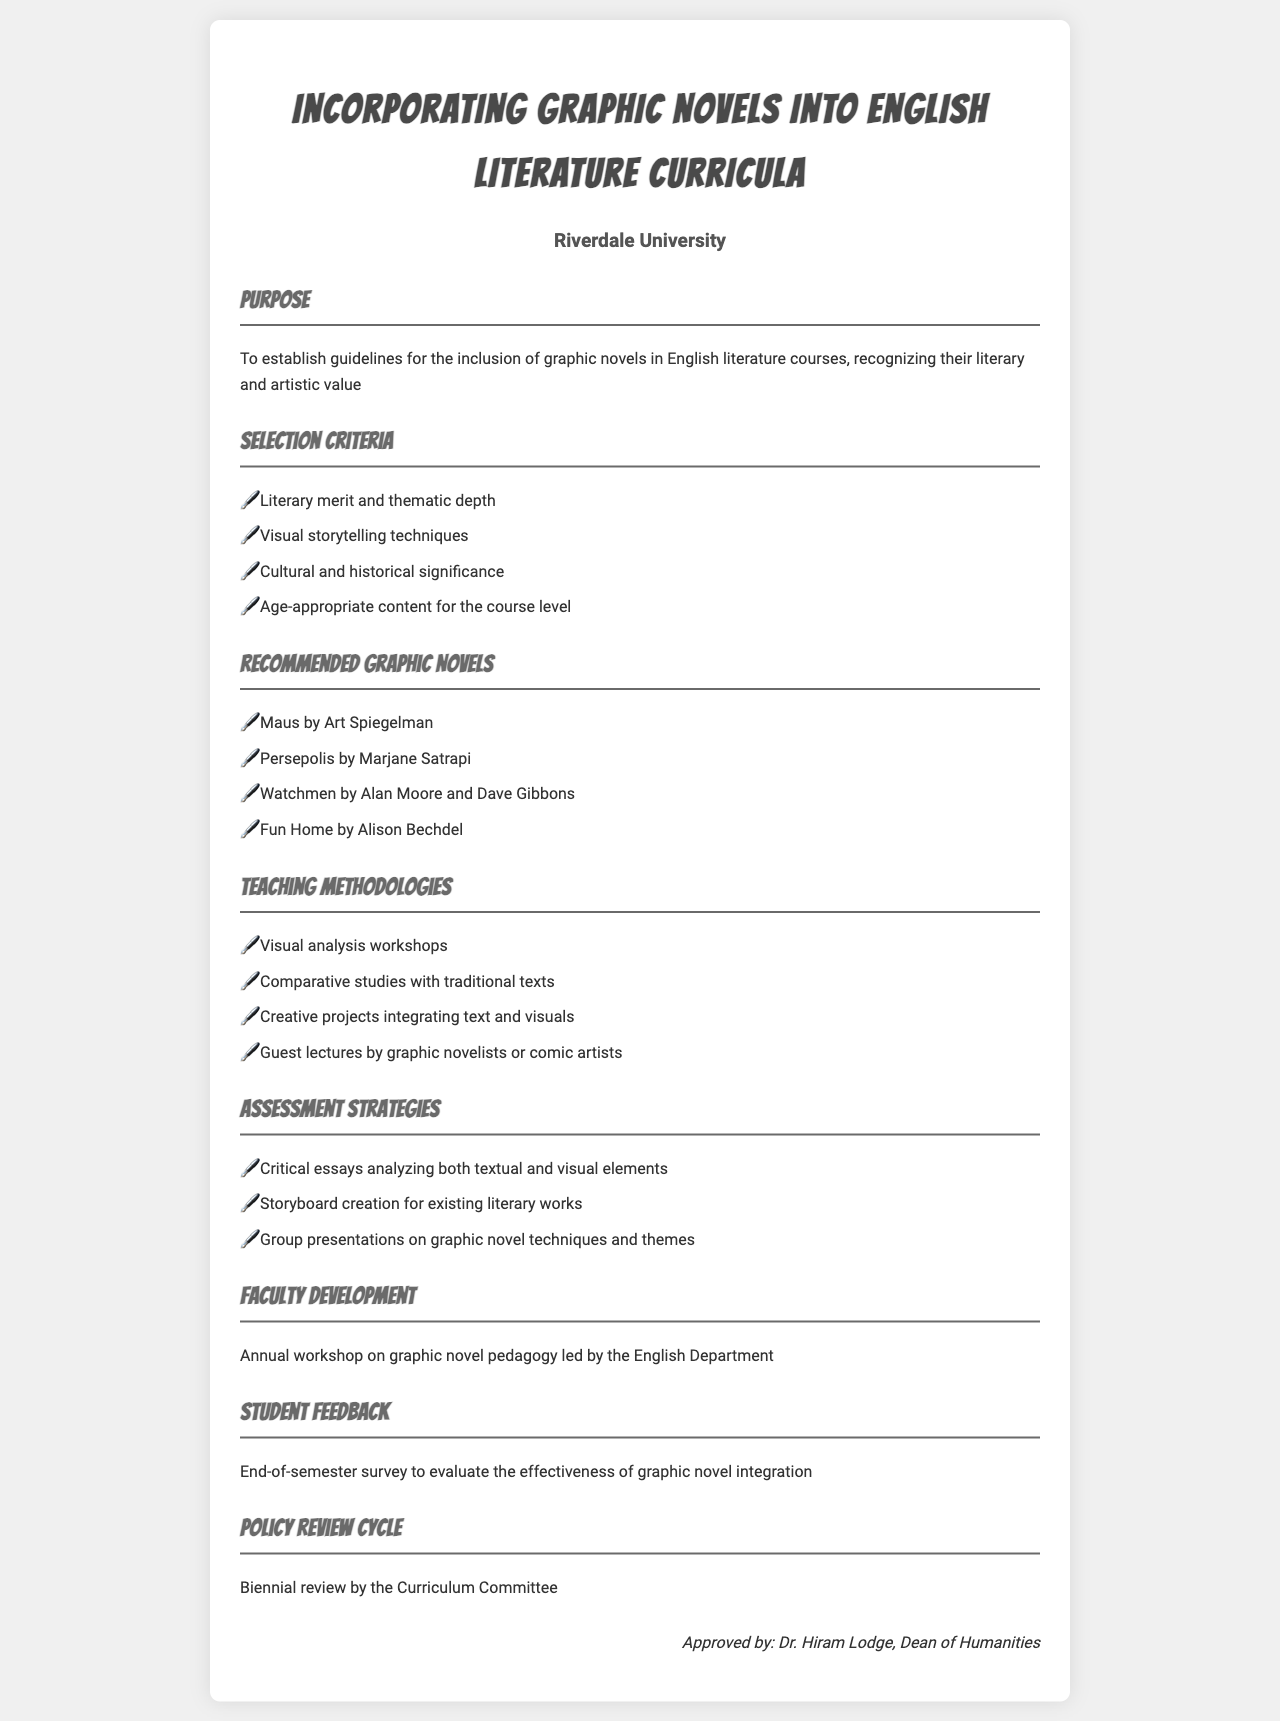what is the purpose of the policy? The purpose is to establish guidelines for the inclusion of graphic novels in English literature courses, recognizing their literary and artistic value.
Answer: To establish guidelines for the inclusion of graphic novels in English literature courses, recognizing their literary and artistic value what is one criterion for selecting graphic novels? The document lists several selection criteria, one of which is literary merit and thematic depth.
Answer: Literary merit and thematic depth how many recommended graphic novels are listed? The document lists four recommended graphic novels.
Answer: Four who approved the policy? The approval of the policy is attributed to Dr. Hiram Lodge, Dean of Humanities.
Answer: Dr. Hiram Lodge, Dean of Humanities what type of assessment strategy is suggested? One suggested assessment strategy is the creation of critical essays analyzing both textual and visual elements.
Answer: Critical essays analyzing both textual and visual elements what is the frequency of the policy review cycle? The policy review cycle is biennial, which means it occurs every two years.
Answer: Biennial name one teaching methodology mentioned in the document. A teaching methodology mentioned is visual analysis workshops.
Answer: Visual analysis workshops what feedback mechanism is stated for students? The document mentions an end-of-semester survey to evaluate the effectiveness of graphic novel integration.
Answer: End-of-semester survey 